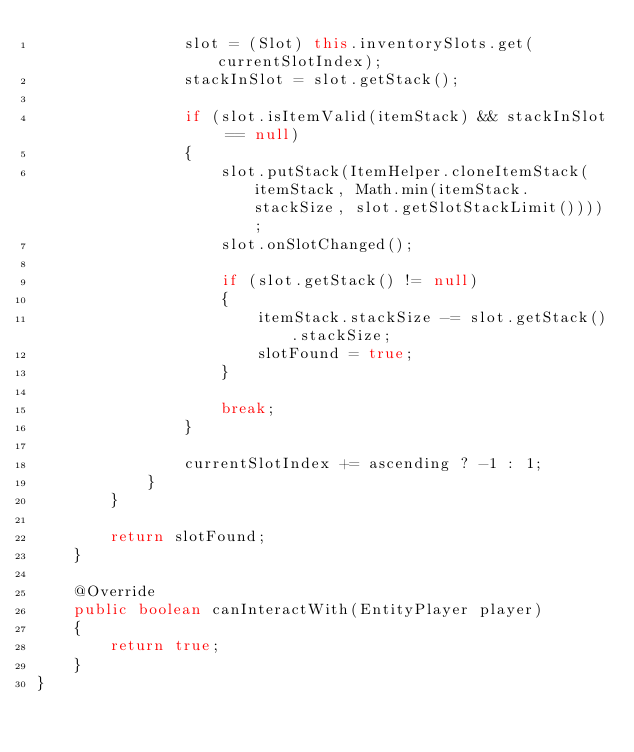Convert code to text. <code><loc_0><loc_0><loc_500><loc_500><_Java_>                slot = (Slot) this.inventorySlots.get(currentSlotIndex);
                stackInSlot = slot.getStack();

                if (slot.isItemValid(itemStack) && stackInSlot == null)
                {
                    slot.putStack(ItemHelper.cloneItemStack(itemStack, Math.min(itemStack.stackSize, slot.getSlotStackLimit())));
                    slot.onSlotChanged();

                    if (slot.getStack() != null)
                    {
                        itemStack.stackSize -= slot.getStack().stackSize;
                        slotFound = true;
                    }

                    break;
                }

                currentSlotIndex += ascending ? -1 : 1;
            }
        }

        return slotFound;
    }

    @Override
    public boolean canInteractWith(EntityPlayer player)
    {
        return true;
    }
}
</code> 